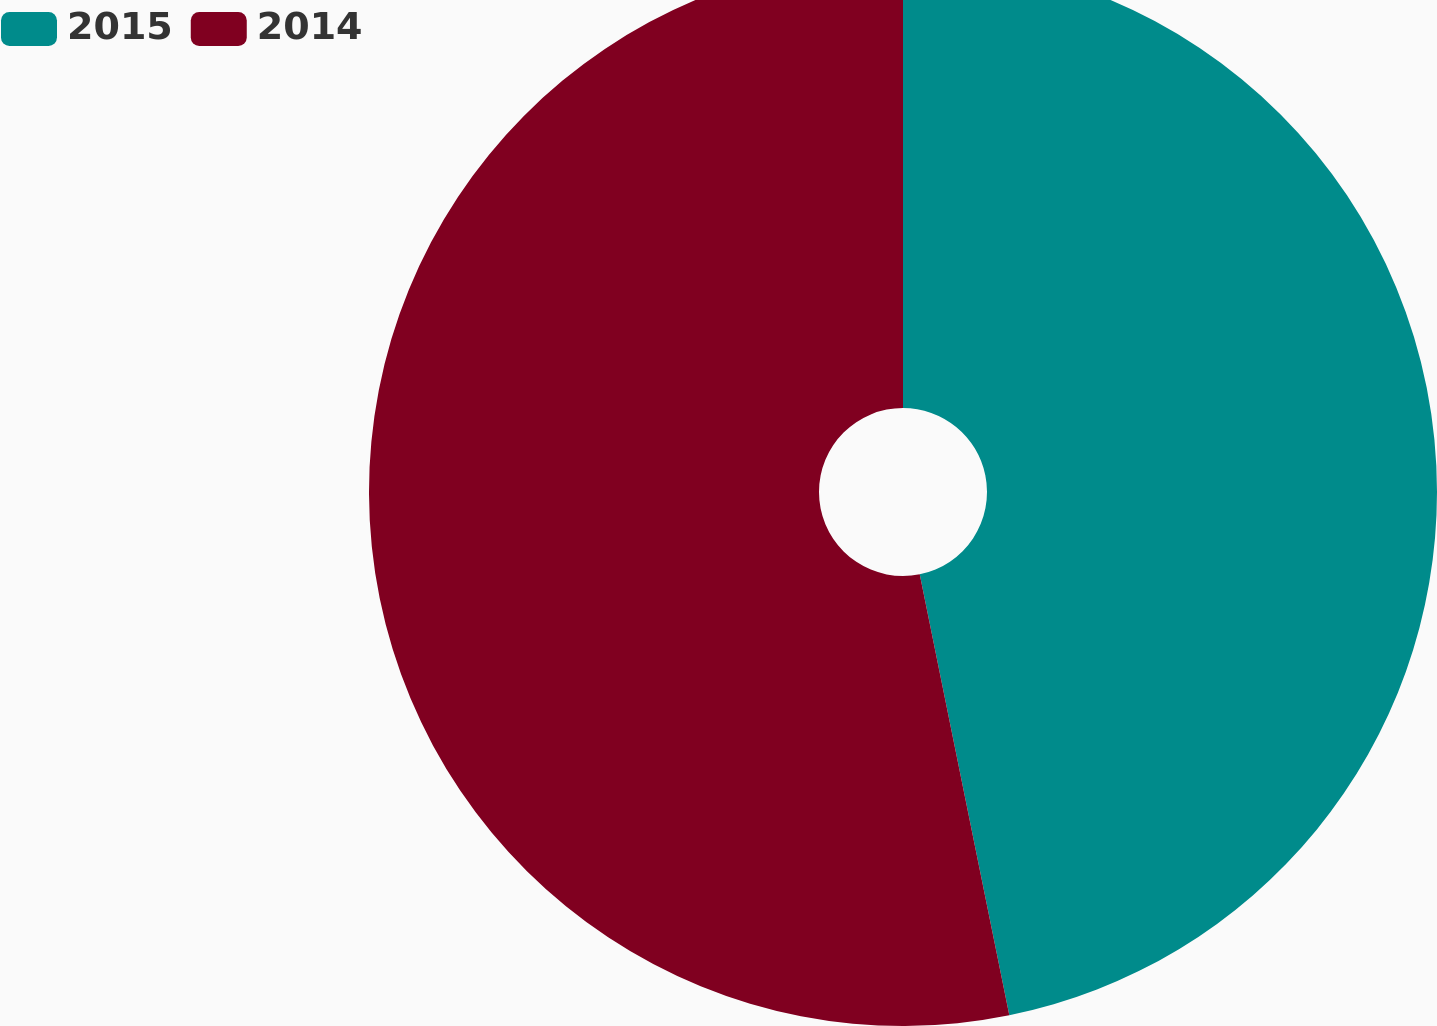<chart> <loc_0><loc_0><loc_500><loc_500><pie_chart><fcel>2015<fcel>2014<nl><fcel>46.81%<fcel>53.19%<nl></chart> 